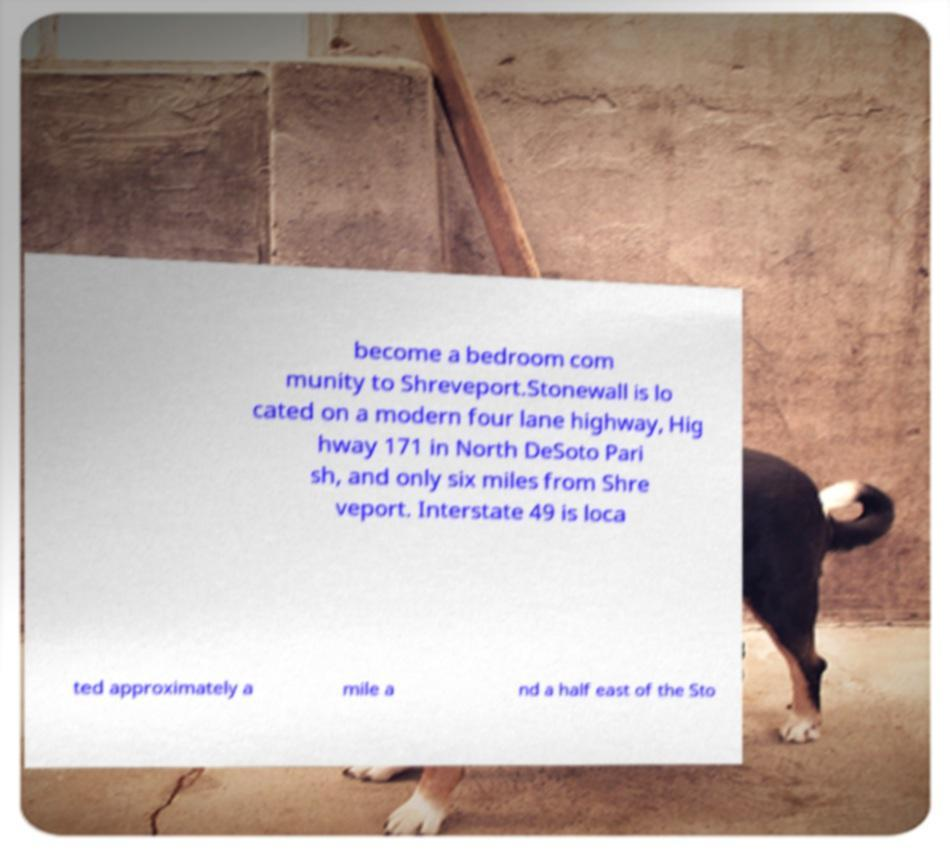I need the written content from this picture converted into text. Can you do that? become a bedroom com munity to Shreveport.Stonewall is lo cated on a modern four lane highway, Hig hway 171 in North DeSoto Pari sh, and only six miles from Shre veport. Interstate 49 is loca ted approximately a mile a nd a half east of the Sto 